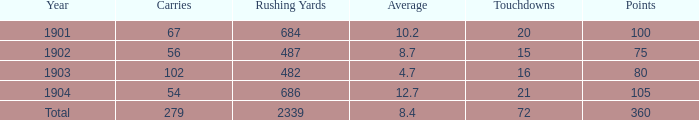How many carries have an average under 8.7 and touchdowns of 72? 1.0. 